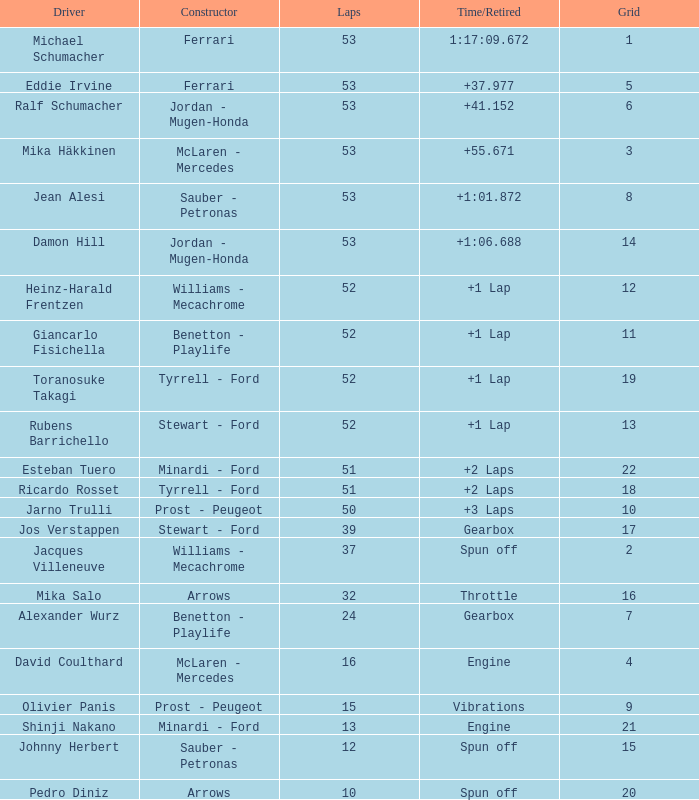Who built the car that went 53 laps with a Time/Retired of 1:17:09.672? Ferrari. 